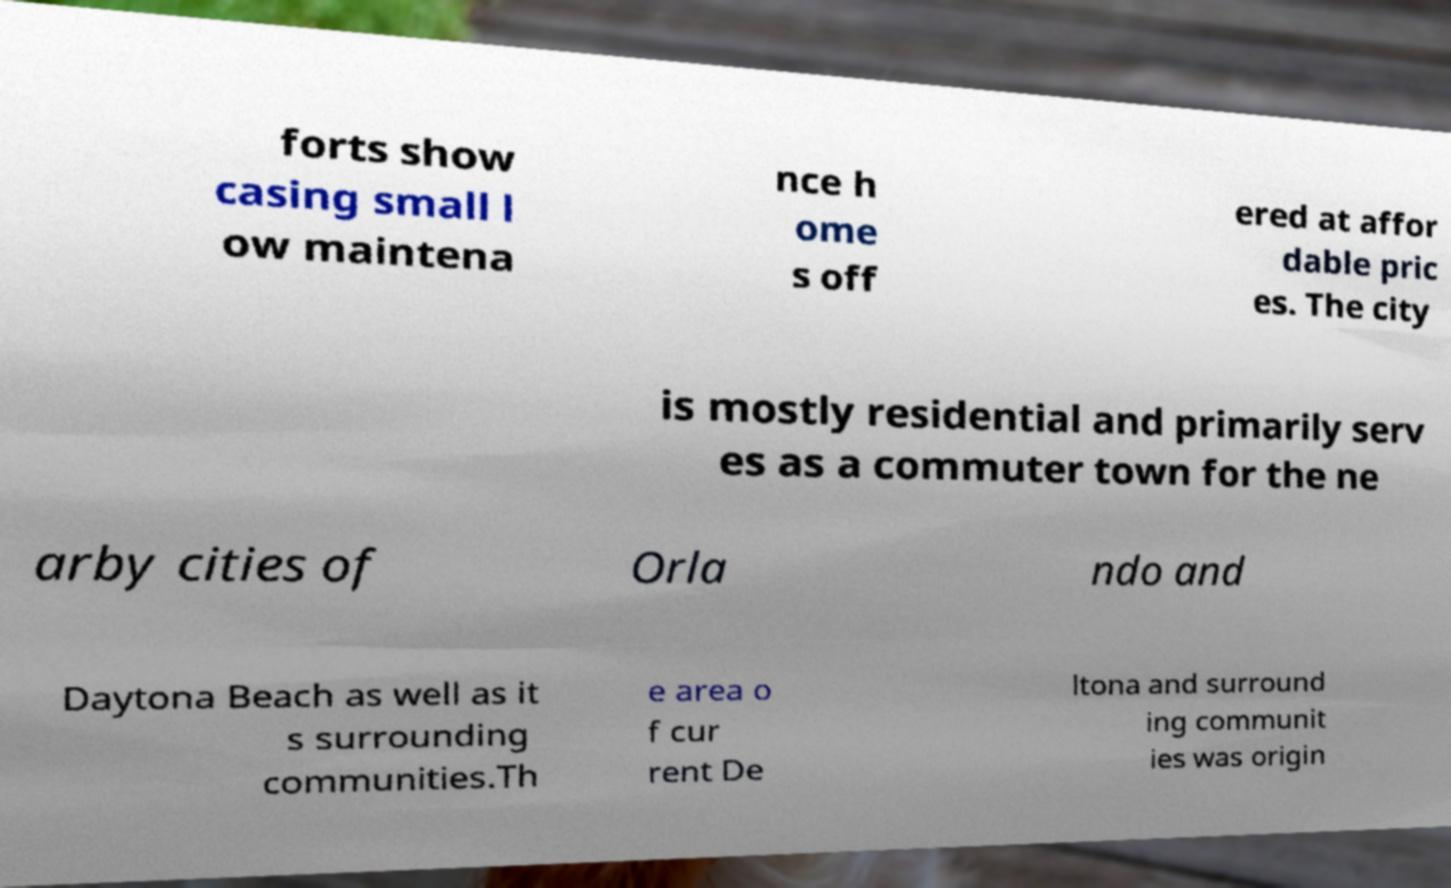What messages or text are displayed in this image? I need them in a readable, typed format. forts show casing small l ow maintena nce h ome s off ered at affor dable pric es. The city is mostly residential and primarily serv es as a commuter town for the ne arby cities of Orla ndo and Daytona Beach as well as it s surrounding communities.Th e area o f cur rent De ltona and surround ing communit ies was origin 